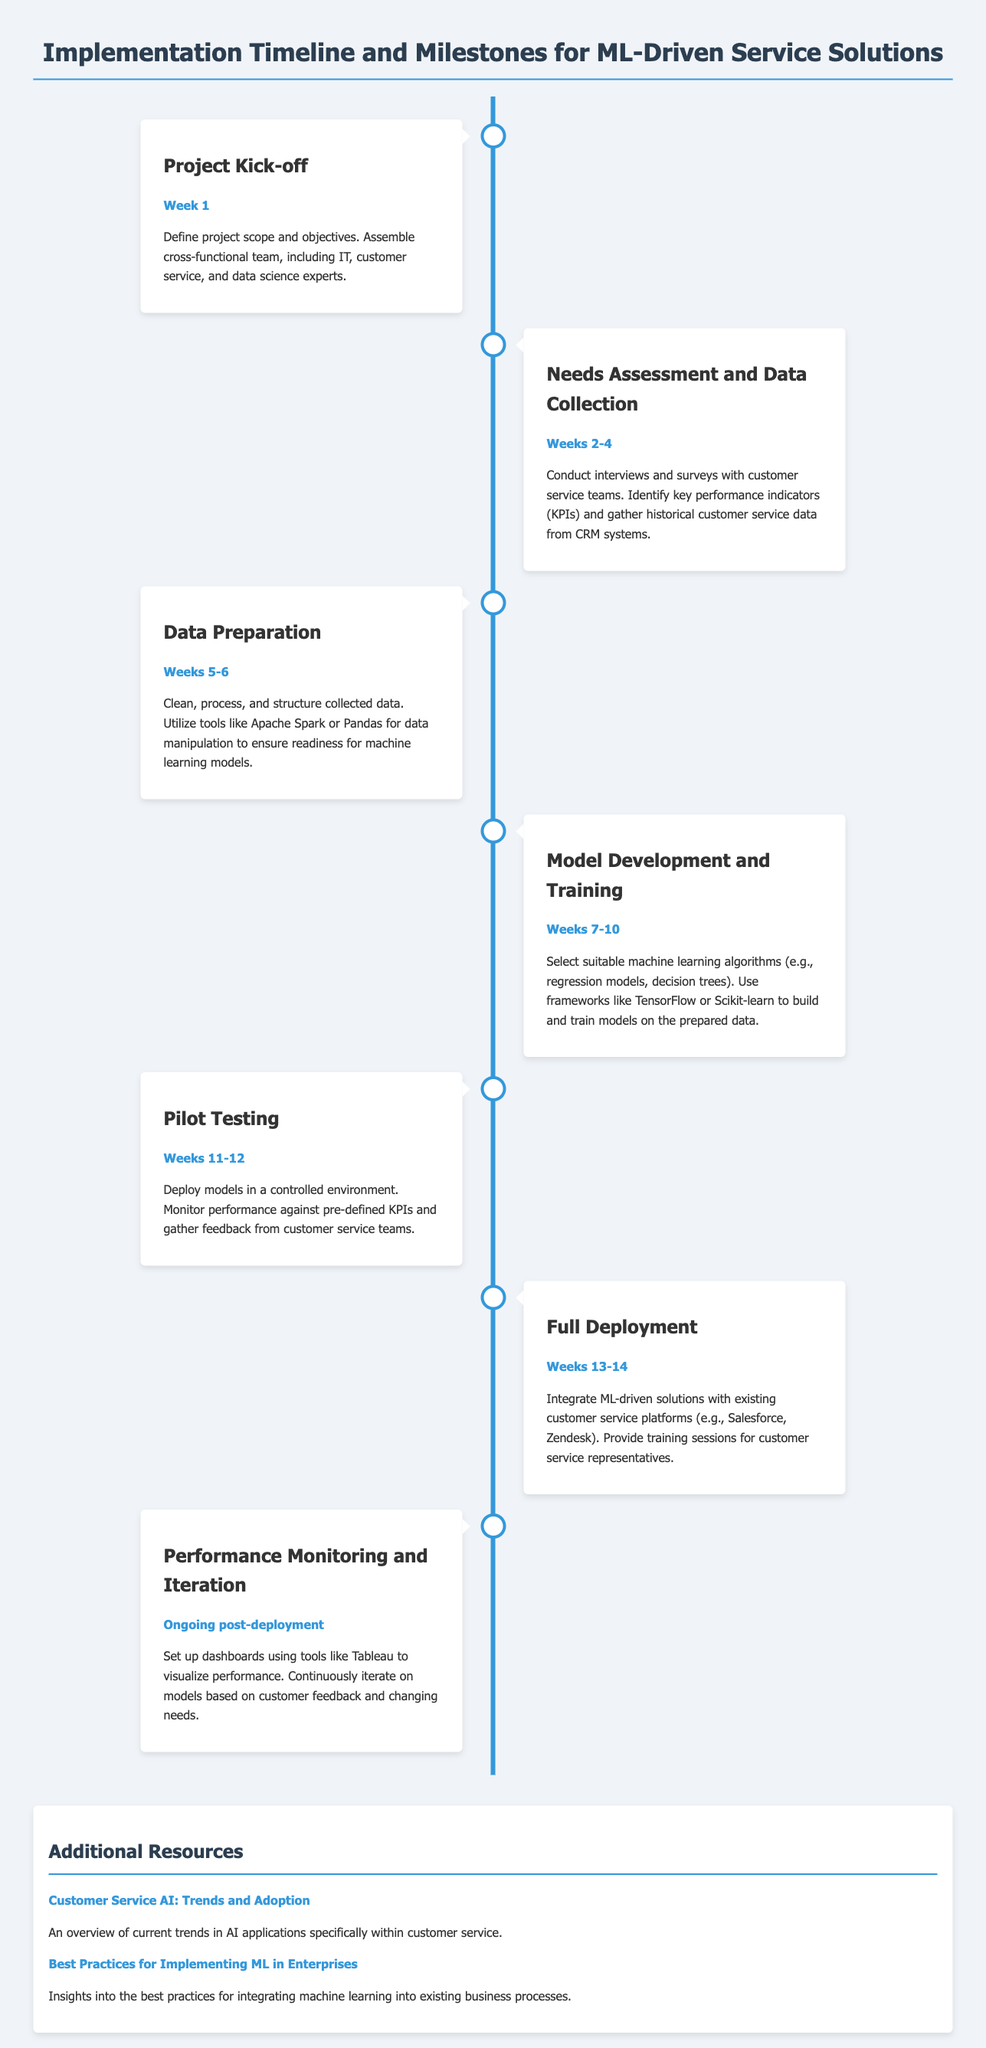What is the duration of the Project Kick-off phase? The duration of the Project Kick-off phase is mentioned as Week 1.
Answer: Week 1 What are the weeks allocated for Needs Assessment and Data Collection? The weeks allocated for Needs Assessment and Data Collection are specified as Weeks 2-4.
Answer: Weeks 2-4 Which framework is recommended for model development and training? The recommendation for the framework during model development and training includes TensorFlow or Scikit-learn.
Answer: TensorFlow or Scikit-learn What key activities take place during Pilot Testing? During Pilot Testing, the key activities include deploying models in a controlled environment and monitoring performance.
Answer: Deploying models and monitoring performance How long is the Performance Monitoring and Iteration phase expected to occur? The Performance Monitoring and Iteration phase is described as ongoing post-deployment.
Answer: Ongoing post-deployment What is the main focus of the resources section? The main focus of the resources section is to provide additional insights and best practices related to AI and machine learning in customer service.
Answer: Insights and best practices How many total weeks are planned for Full Deployment? Full Deployment is scheduled for a total of two weeks according to the document.
Answer: Two weeks What is the primary goal of the Needs Assessment and Data Collection phase? The primary goal of the Needs Assessment and Data Collection phase is to identify key performance indicators and gather historical data.
Answer: Identify KPIs and gather data What milestone comes after Model Development and Training? The milestone that comes after Model Development and Training is the Pilot Testing phase.
Answer: Pilot Testing 